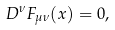<formula> <loc_0><loc_0><loc_500><loc_500>D ^ { \nu } F _ { \mu \nu } ( x ) = 0 ,</formula> 